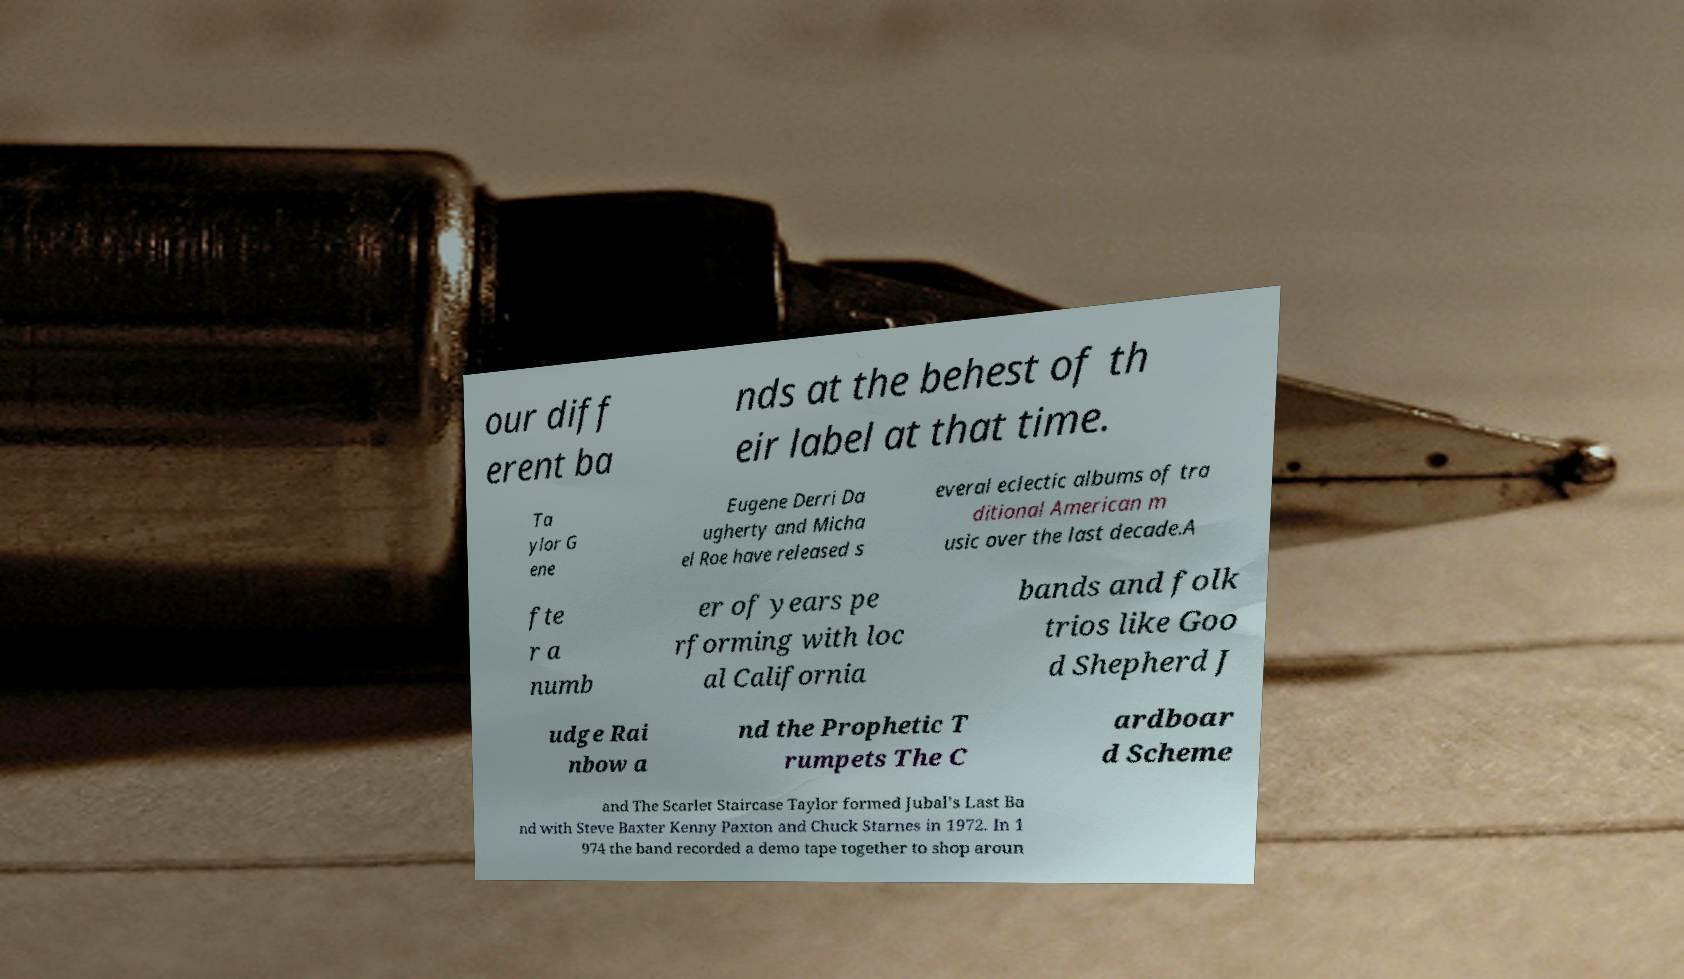Can you accurately transcribe the text from the provided image for me? our diff erent ba nds at the behest of th eir label at that time. Ta ylor G ene Eugene Derri Da ugherty and Micha el Roe have released s everal eclectic albums of tra ditional American m usic over the last decade.A fte r a numb er of years pe rforming with loc al California bands and folk trios like Goo d Shepherd J udge Rai nbow a nd the Prophetic T rumpets The C ardboar d Scheme and The Scarlet Staircase Taylor formed Jubal's Last Ba nd with Steve Baxter Kenny Paxton and Chuck Starnes in 1972. In 1 974 the band recorded a demo tape together to shop aroun 